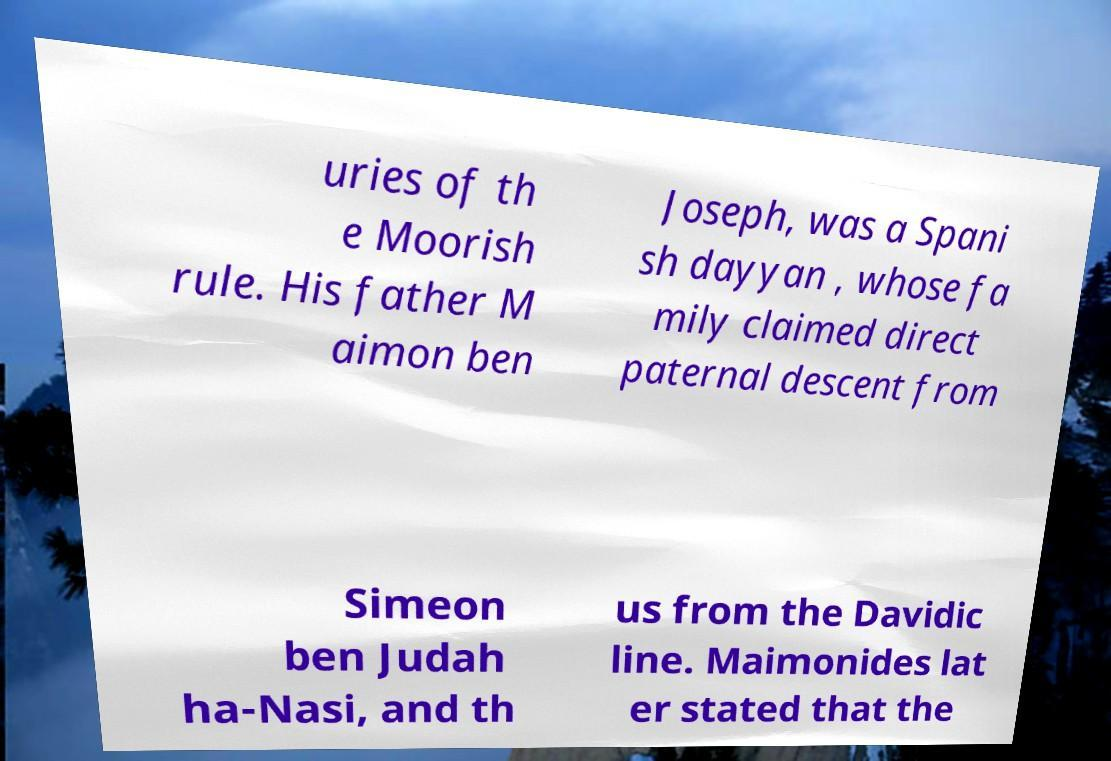Could you extract and type out the text from this image? uries of th e Moorish rule. His father M aimon ben Joseph, was a Spani sh dayyan , whose fa mily claimed direct paternal descent from Simeon ben Judah ha-Nasi, and th us from the Davidic line. Maimonides lat er stated that the 